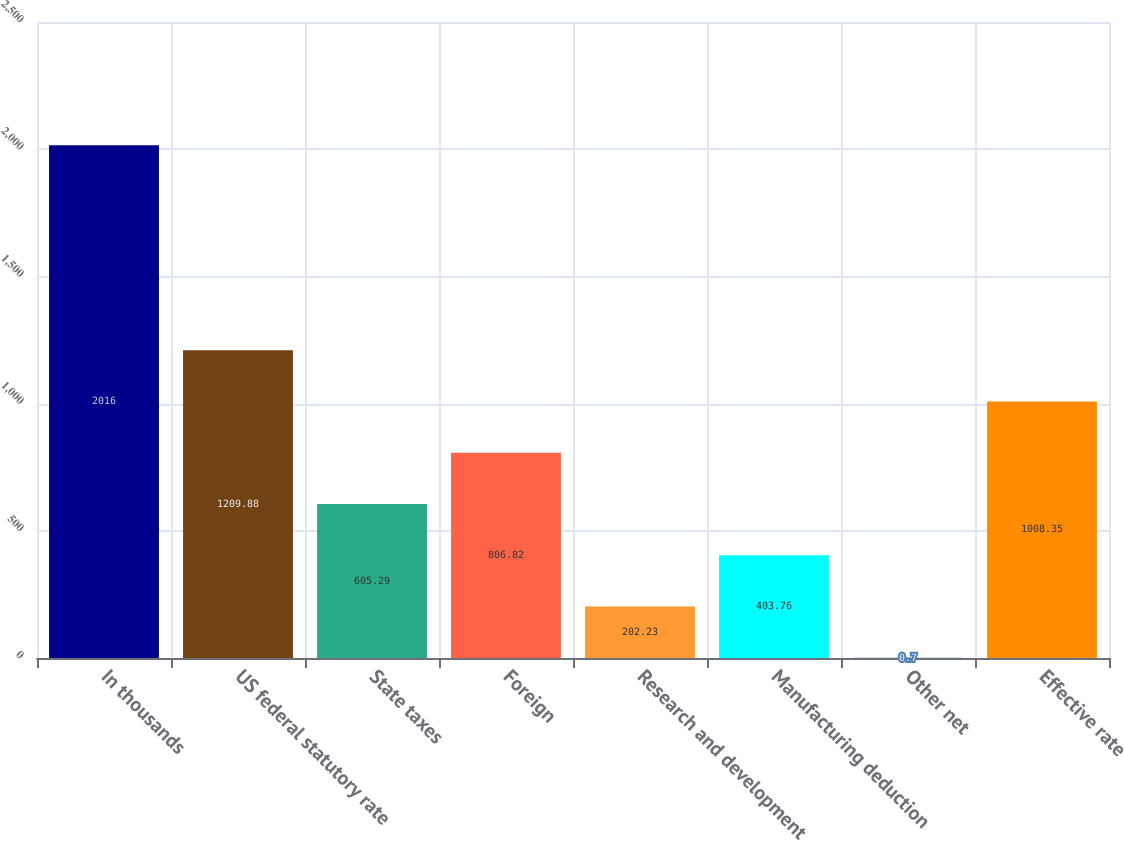<chart> <loc_0><loc_0><loc_500><loc_500><bar_chart><fcel>In thousands<fcel>US federal statutory rate<fcel>State taxes<fcel>Foreign<fcel>Research and development<fcel>Manufacturing deduction<fcel>Other net<fcel>Effective rate<nl><fcel>2016<fcel>1209.88<fcel>605.29<fcel>806.82<fcel>202.23<fcel>403.76<fcel>0.7<fcel>1008.35<nl></chart> 